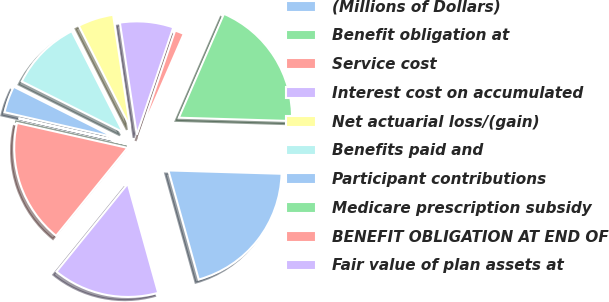<chart> <loc_0><loc_0><loc_500><loc_500><pie_chart><fcel>(Millions of Dollars)<fcel>Benefit obligation at<fcel>Service cost<fcel>Interest cost on accumulated<fcel>Net actuarial loss/(gain)<fcel>Benefits paid and<fcel>Participant contributions<fcel>Medicare prescription subsidy<fcel>BENEFIT OBLIGATION AT END OF<fcel>Fair value of plan assets at<nl><fcel>20.21%<fcel>18.95%<fcel>1.3%<fcel>7.61%<fcel>5.09%<fcel>10.13%<fcel>3.82%<fcel>0.04%<fcel>17.69%<fcel>15.17%<nl></chart> 